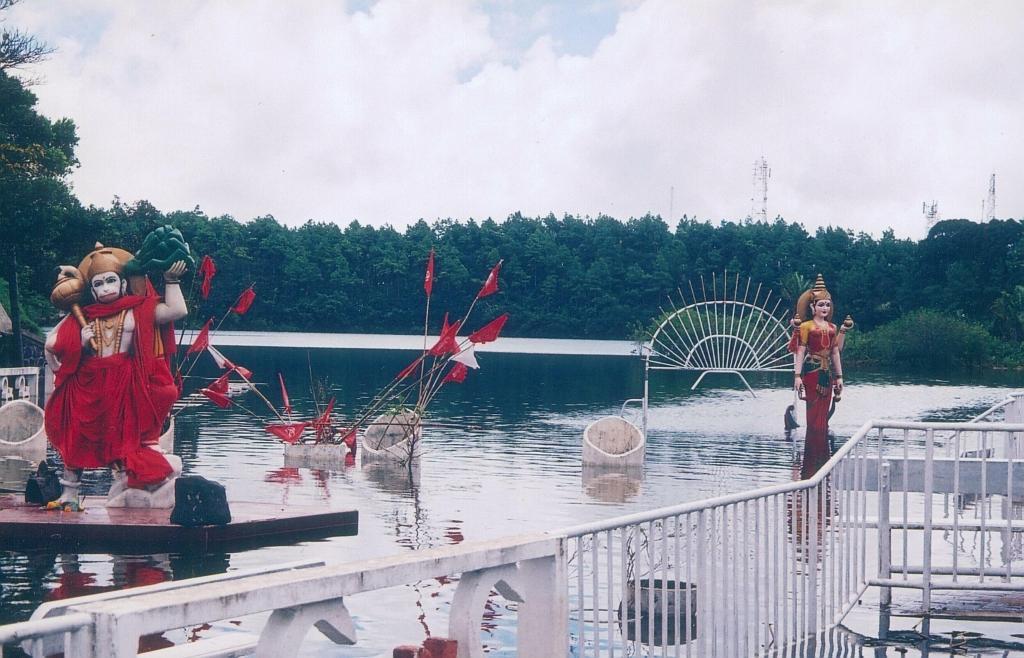In one or two sentences, can you explain what this image depicts? In this picture there are trees. In the foreground there are idols on the water and there are flags and there are objects on the water and there is a railing. At the back there are towers. At the top there is sky and there are clouds. At the bottom there is water. 